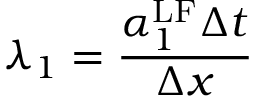<formula> <loc_0><loc_0><loc_500><loc_500>\lambda _ { 1 } = \frac { \alpha _ { 1 } ^ { L F } \Delta t } { \Delta x }</formula> 